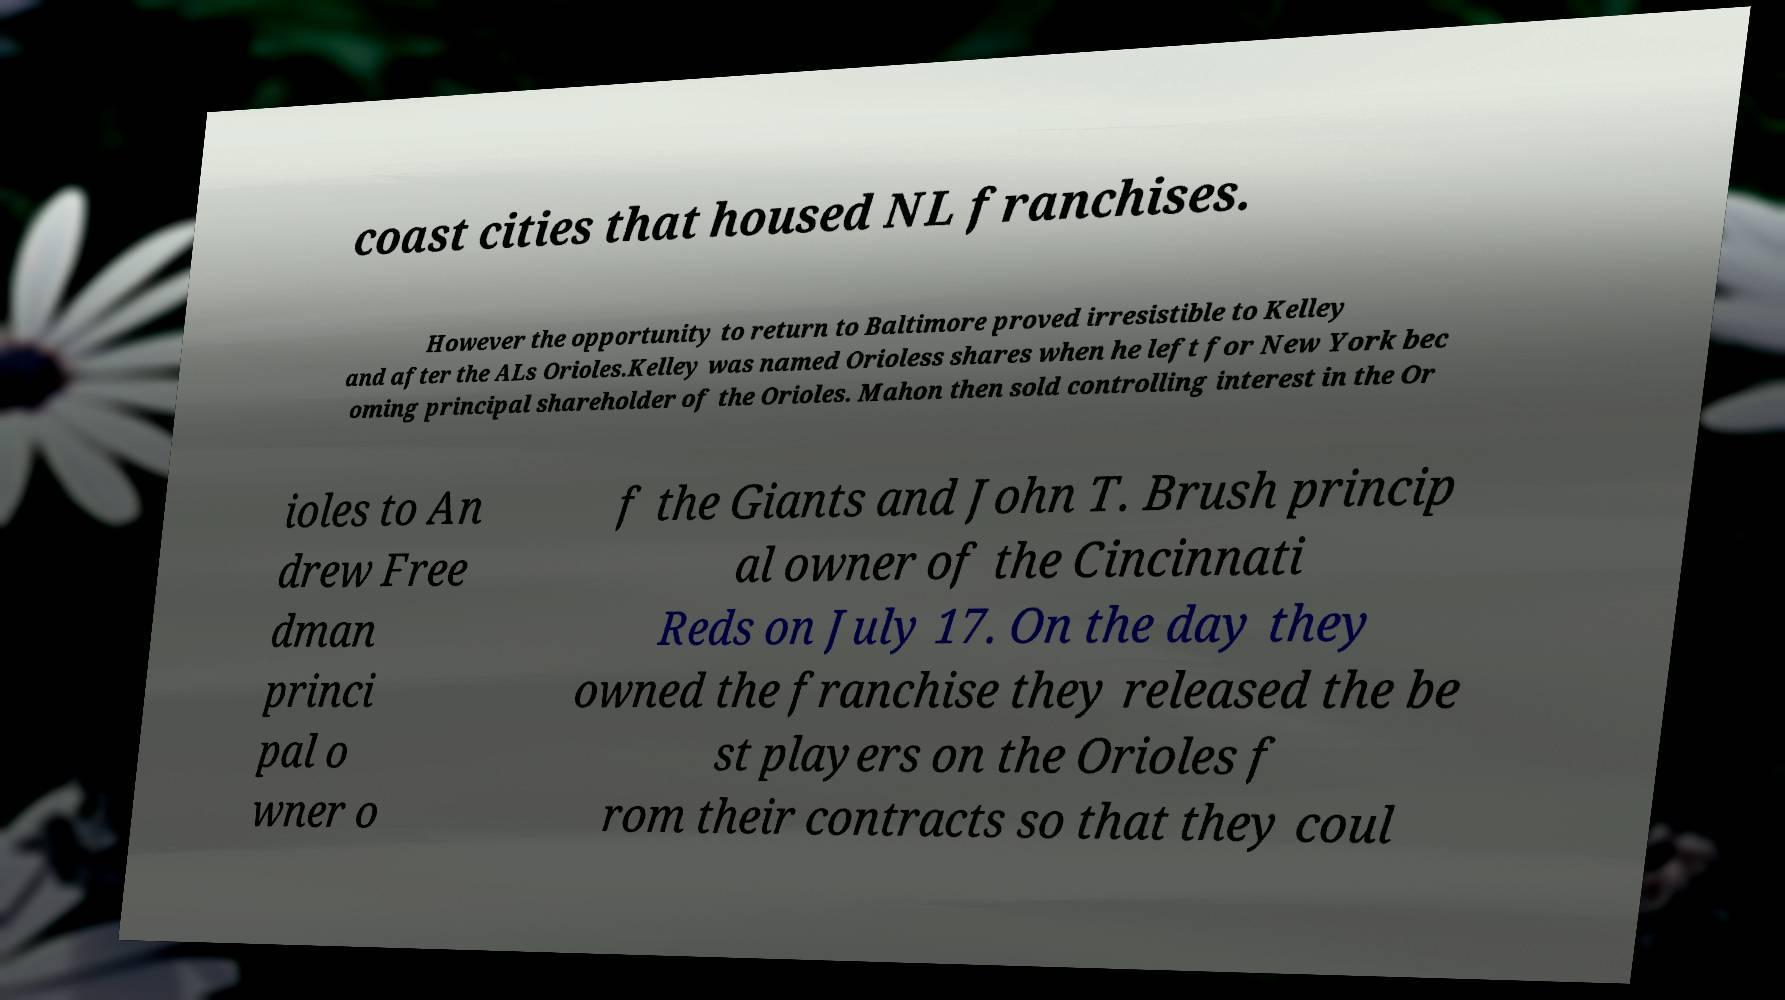I need the written content from this picture converted into text. Can you do that? coast cities that housed NL franchises. However the opportunity to return to Baltimore proved irresistible to Kelley and after the ALs Orioles.Kelley was named Orioless shares when he left for New York bec oming principal shareholder of the Orioles. Mahon then sold controlling interest in the Or ioles to An drew Free dman princi pal o wner o f the Giants and John T. Brush princip al owner of the Cincinnati Reds on July 17. On the day they owned the franchise they released the be st players on the Orioles f rom their contracts so that they coul 